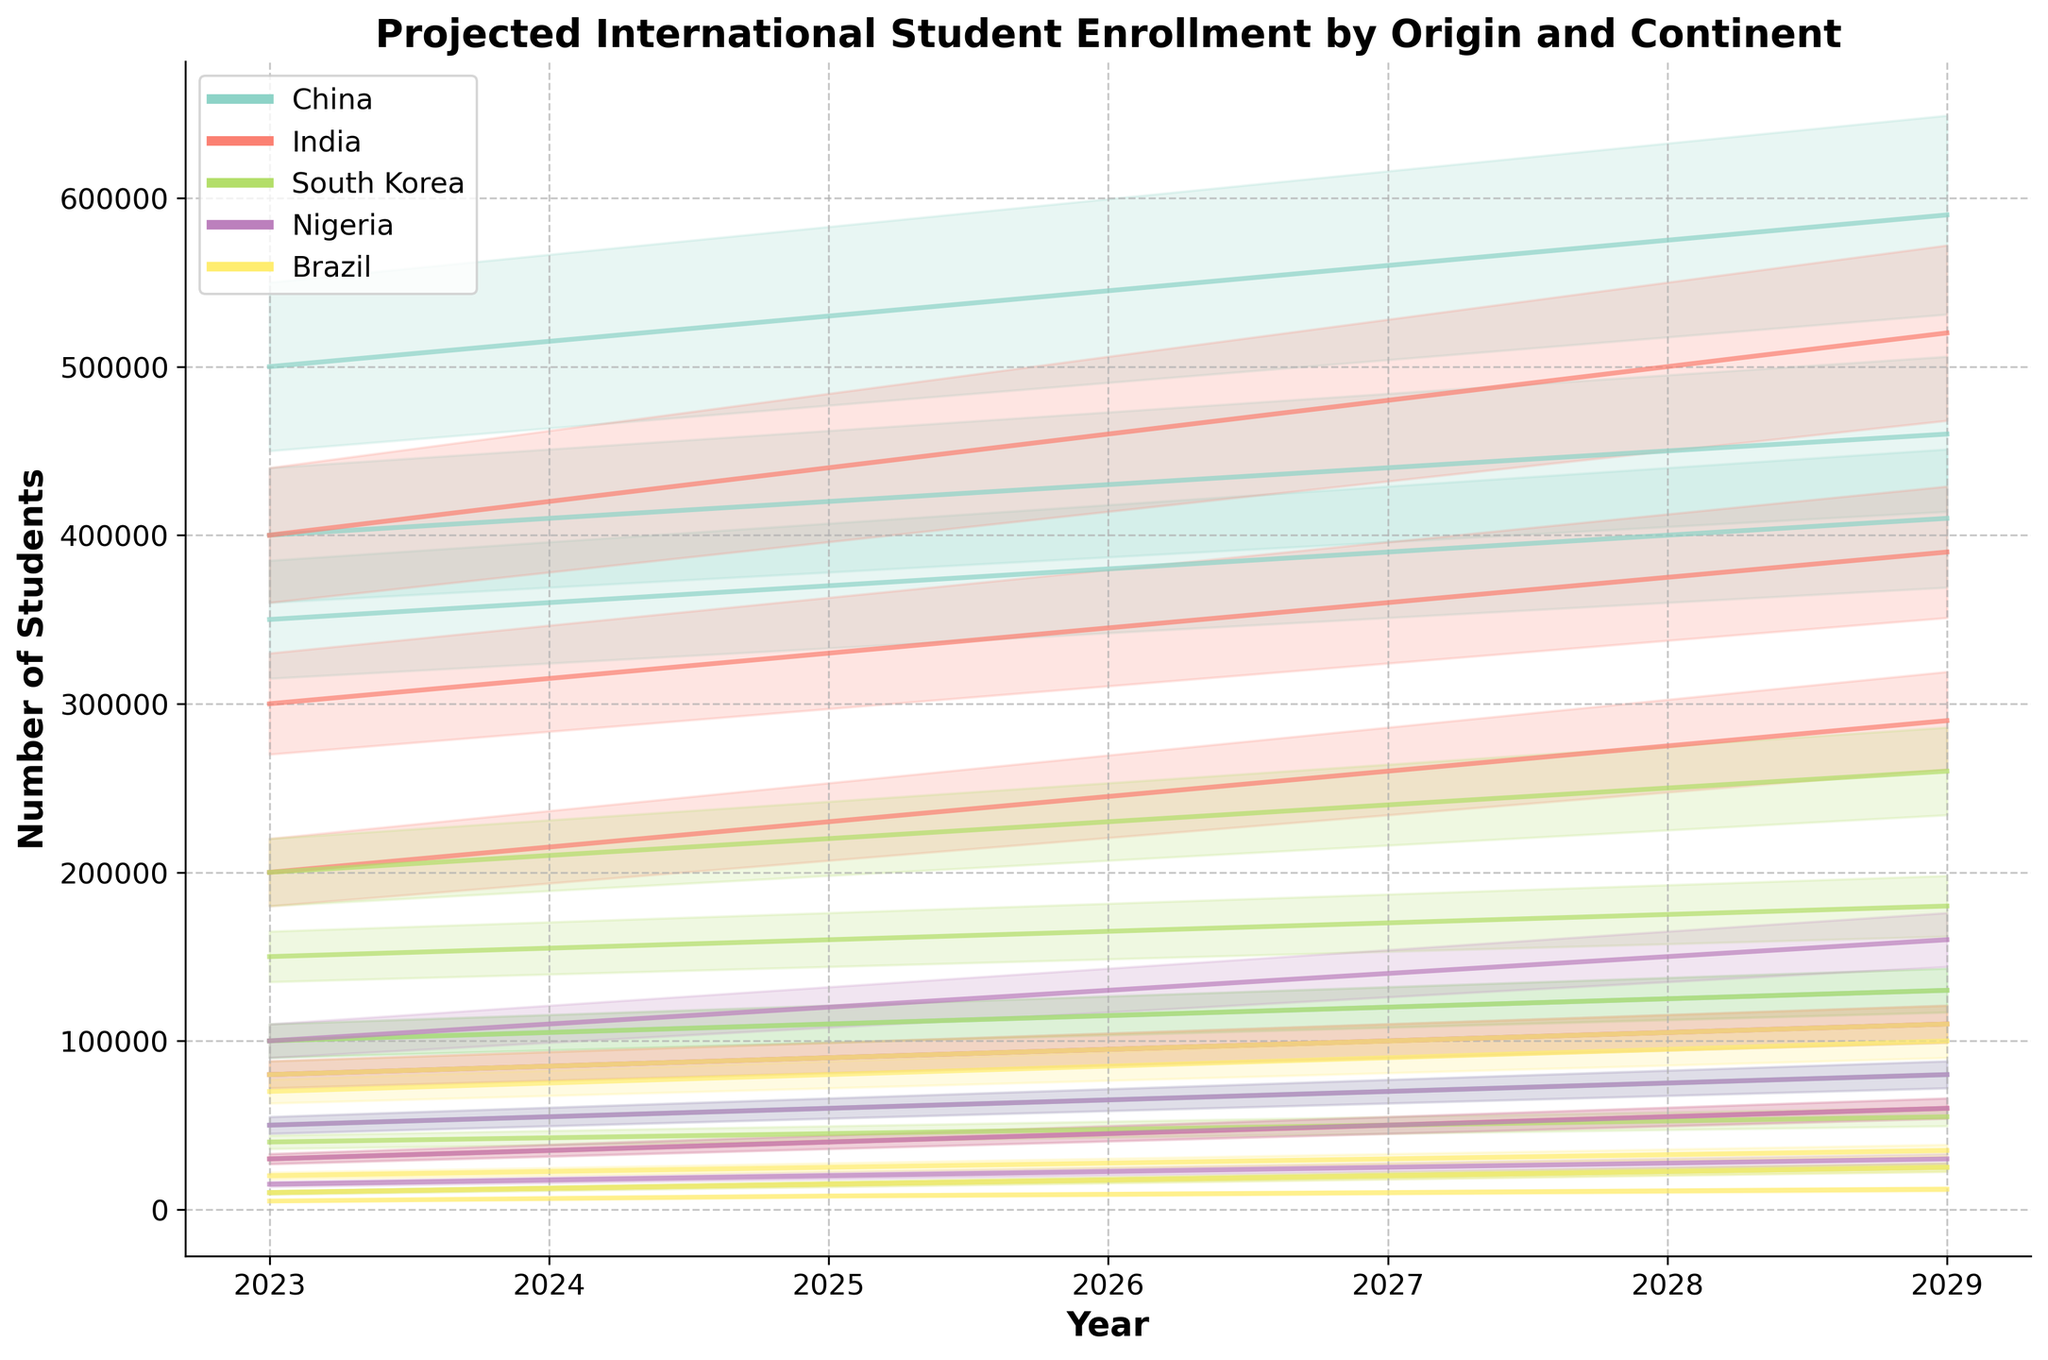What's the title of the figure? The title of the figure is usually displayed at the top, in this case, it reads 'Projected International Student Enrollment by Origin and Continent'.
Answer: Projected International Student Enrollment by Origin and Continent Which country has the highest projected number of students in Asia in 2025? The figure shows the number of students on the y-axis and the continents are plotted with different colors. For Asia in 2025, China has the highest value.
Answer: China By how much is the projected number of Indian students in Europe expected to increase from 2023 to 2029? The projected number of Indian students in Europe in 2023 is 200,000 and in 2029 it is 290,000. The difference is 290,000 - 200,000.
Answer: 90,000 Which continent has the lowest expected number of Brazilian students in 2027? The figure has multiple lines for Brazil across different continents. Oceania has the lowest value for 2027, which is 10,000.
Answer: Oceania How does the projected number of Nigerian students in North America change from 2023 to 2027? Observing the line for Nigeria in North America from 2023 to 2027, the values increase from 50,000 to 70,000.
Answer: Increases by 20,000 Which country is projected to have the highest student enrollment in Africa in 2029? For Africa, the figure shows multiple lines and Nigeria has the highest value in 2029, which is 160,000.
Answer: Nigeria What is the projected increase in the number of Chinese students in Oceania from 2023 to 2029? The projected number of Chinese students in Oceania increases from 100,000 in 2023 to 130,000 in 2029. The difference is 130,000 - 100,000.
Answer: 30,000 Compare the projected trends of Indian and Brazilian students in Europe in 2025 and determine the difference. For Indian students in Europe in 2025, the number is 230,000. For Brazilian students, it's 80,000. The difference is 230,000 - 80,000.
Answer: 150,000 What is the average projected number of South Korean students in North America over the years 2023, 2025, and 2027? The values for South Korean students in North America are 150,000 in 2023, 160,000 in 2025, and 170,000 in 2027. The average is (150,000 + 160,000 + 170,000) / 3.
Answer: 160,000 Which continent shows the least variance in projected student numbers from Nigeria between 2023 and 2029? Observing the lines for Nigeria across all continents, the projection in Oceania shows the least change (15,000 to 30,000).
Answer: Oceania 